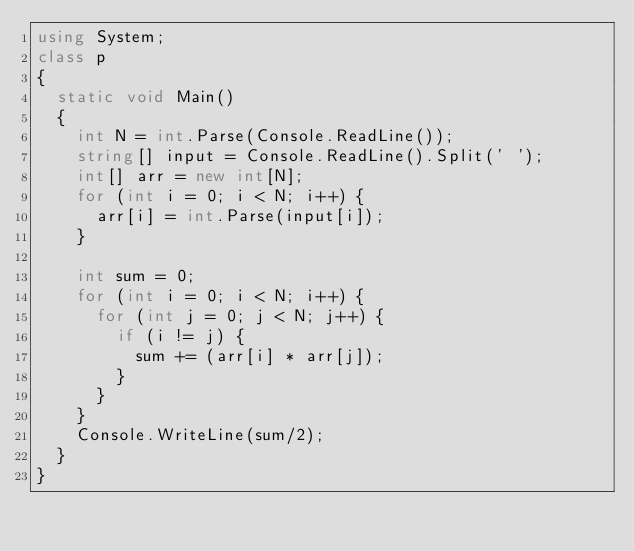Convert code to text. <code><loc_0><loc_0><loc_500><loc_500><_C#_>using System;
class p
{
  static void Main()
  {
    int N = int.Parse(Console.ReadLine());
    string[] input = Console.ReadLine().Split(' ');
    int[] arr = new int[N];
    for (int i = 0; i < N; i++) {
      arr[i] = int.Parse(input[i]);
    }
    
    int sum = 0;
    for (int i = 0; i < N; i++) {
      for (int j = 0; j < N; j++) {
        if (i != j) {
          sum += (arr[i] * arr[j]);
        }
      }
    }
    Console.WriteLine(sum/2);
  }
}</code> 